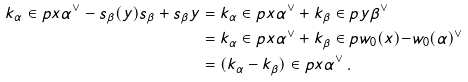<formula> <loc_0><loc_0><loc_500><loc_500>k _ { \alpha } \in p { x } { \alpha ^ { \vee } } - s _ { \beta } ( y ) s _ { \beta } + s _ { \beta } y & = k _ { \alpha } \in p { x } { \alpha ^ { \vee } } + k _ { \beta } \in p { y } { \beta ^ { \vee } } \\ & = k _ { \alpha } \in p { x } { \alpha ^ { \vee } } + k _ { \beta } \in p { w _ { 0 } ( x ) } { - w _ { 0 } ( \alpha ) ^ { \vee } } \\ & = ( k _ { \alpha } - k _ { \beta } ) \in p { x } { \alpha ^ { \vee } } \, .</formula> 